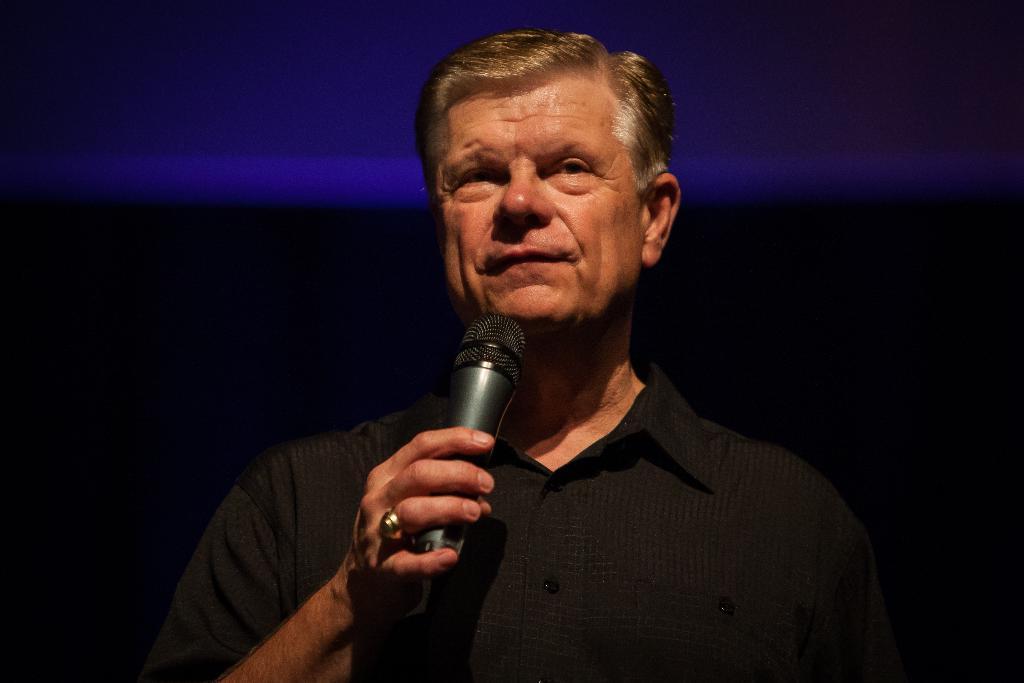In one or two sentences, can you explain what this image depicts? In this picture we can see a man holding a microphone, we can see a dark background. 